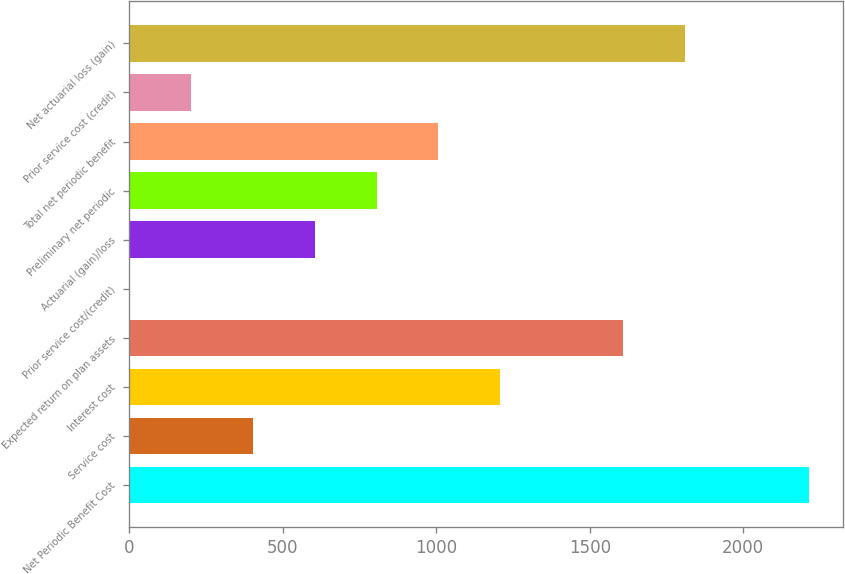Convert chart to OTSL. <chart><loc_0><loc_0><loc_500><loc_500><bar_chart><fcel>Net Periodic Benefit Cost<fcel>Service cost<fcel>Interest cost<fcel>Expected return on plan assets<fcel>Prior service cost/(credit)<fcel>Actuarial (gain)/loss<fcel>Preliminary net periodic<fcel>Total net periodic benefit<fcel>Prior service cost (credit)<fcel>Net actuarial loss (gain)<nl><fcel>2213.07<fcel>403.44<fcel>1207.72<fcel>1609.86<fcel>1.3<fcel>604.51<fcel>805.58<fcel>1006.65<fcel>202.37<fcel>1810.93<nl></chart> 